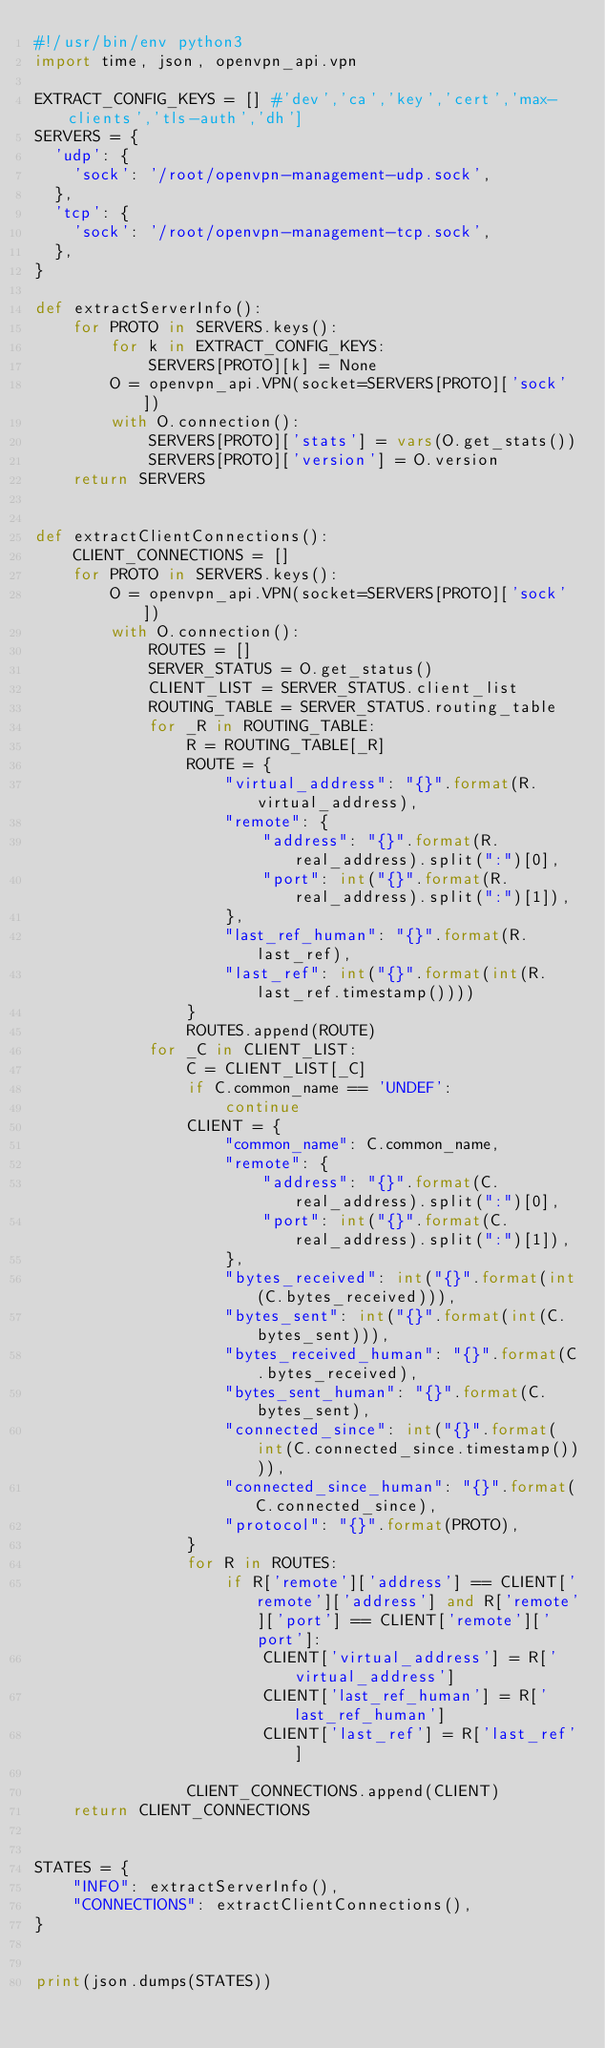Convert code to text. <code><loc_0><loc_0><loc_500><loc_500><_Python_>#!/usr/bin/env python3
import time, json, openvpn_api.vpn

EXTRACT_CONFIG_KEYS = [] #'dev','ca','key','cert','max-clients','tls-auth','dh']
SERVERS = {
  'udp': {
    'sock': '/root/openvpn-management-udp.sock',
  },
  'tcp': {
    'sock': '/root/openvpn-management-tcp.sock',
  },
}

def extractServerInfo():
    for PROTO in SERVERS.keys():
        for k in EXTRACT_CONFIG_KEYS:
            SERVERS[PROTO][k] = None
        O = openvpn_api.VPN(socket=SERVERS[PROTO]['sock'])
        with O.connection():
            SERVERS[PROTO]['stats'] = vars(O.get_stats())
            SERVERS[PROTO]['version'] = O.version
    return SERVERS


def extractClientConnections():
    CLIENT_CONNECTIONS = []
    for PROTO in SERVERS.keys():
        O = openvpn_api.VPN(socket=SERVERS[PROTO]['sock'])
        with O.connection():
            ROUTES = []
            SERVER_STATUS = O.get_status()
            CLIENT_LIST = SERVER_STATUS.client_list
            ROUTING_TABLE = SERVER_STATUS.routing_table
            for _R in ROUTING_TABLE:
                R = ROUTING_TABLE[_R]
                ROUTE = {
                    "virtual_address": "{}".format(R.virtual_address),
                    "remote": {
                        "address": "{}".format(R.real_address).split(":")[0],
                        "port": int("{}".format(R.real_address).split(":")[1]),
                    },
                    "last_ref_human": "{}".format(R.last_ref),
                    "last_ref": int("{}".format(int(R.last_ref.timestamp())))
                }
                ROUTES.append(ROUTE)
            for _C in CLIENT_LIST:
                C = CLIENT_LIST[_C]
                if C.common_name == 'UNDEF':
                    continue
                CLIENT = {
                    "common_name": C.common_name,
                    "remote": {
                        "address": "{}".format(C.real_address).split(":")[0],
                        "port": int("{}".format(C.real_address).split(":")[1]),
                    },
                    "bytes_received": int("{}".format(int(C.bytes_received))),
                    "bytes_sent": int("{}".format(int(C.bytes_sent))),
                    "bytes_received_human": "{}".format(C.bytes_received),
                    "bytes_sent_human": "{}".format(C.bytes_sent),
                    "connected_since": int("{}".format(int(C.connected_since.timestamp()))),
                    "connected_since_human": "{}".format(C.connected_since),
                    "protocol": "{}".format(PROTO),
                }
                for R in ROUTES:
                    if R['remote']['address'] == CLIENT['remote']['address'] and R['remote']['port'] == CLIENT['remote']['port']:
                        CLIENT['virtual_address'] = R['virtual_address']
                        CLIENT['last_ref_human'] = R['last_ref_human']
                        CLIENT['last_ref'] = R['last_ref']

                CLIENT_CONNECTIONS.append(CLIENT)
    return CLIENT_CONNECTIONS


STATES = {
    "INFO": extractServerInfo(),
    "CONNECTIONS": extractClientConnections(),
}


print(json.dumps(STATES))
</code> 